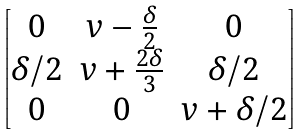<formula> <loc_0><loc_0><loc_500><loc_500>\begin{bmatrix} 0 & v - \frac { \delta } { 2 } & 0 \\ \delta / 2 & v + \frac { 2 \delta } { 3 } & \delta / 2 \\ 0 & 0 & v + \delta / 2 \end{bmatrix}</formula> 